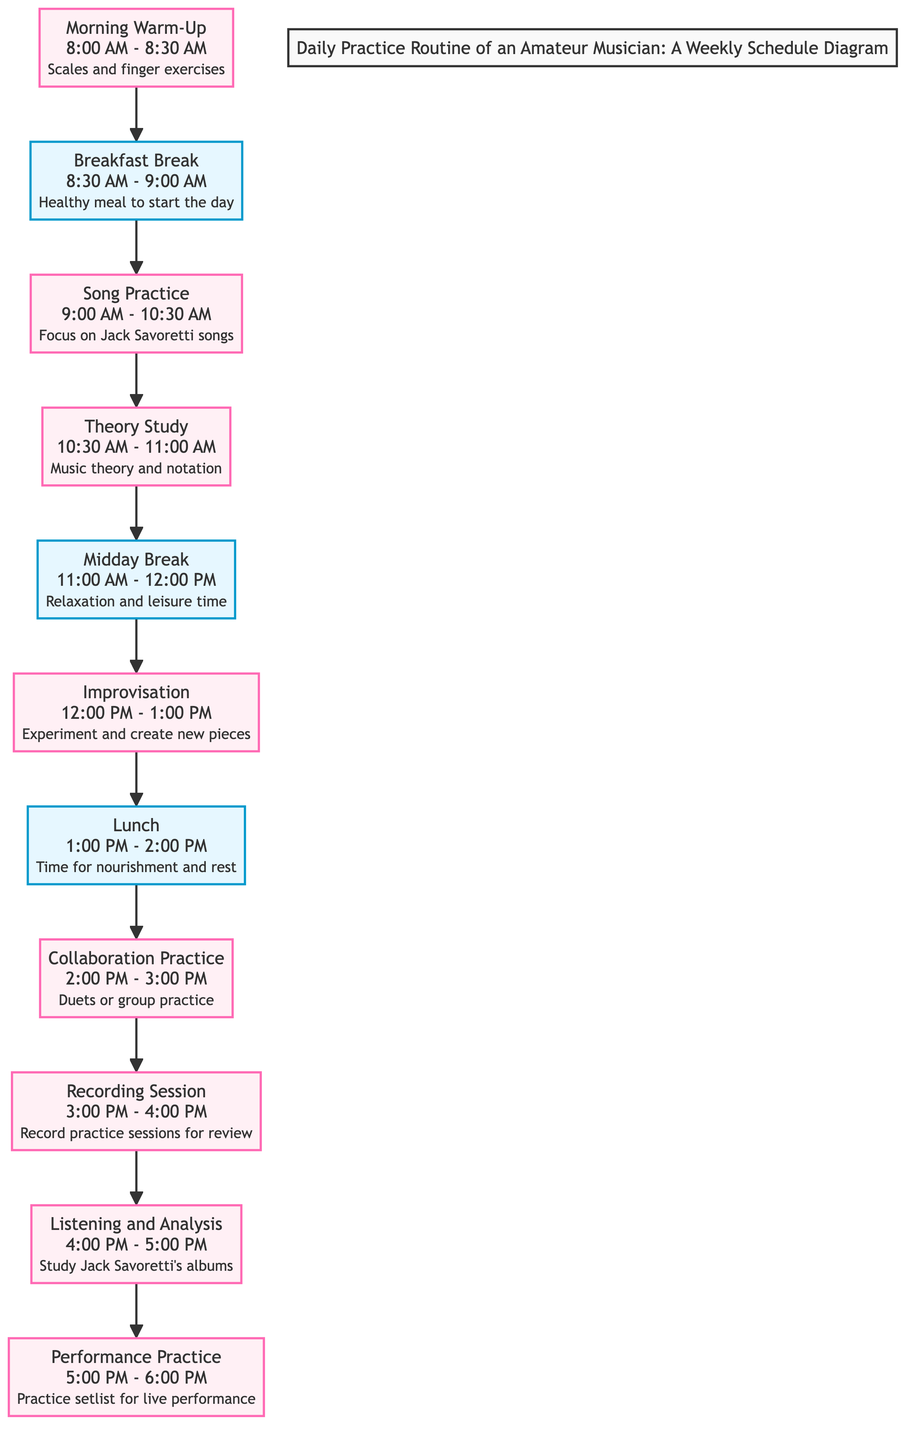What is the first activity in the daily practice routine? The first activity is "Morning Warm-Up", which is the topmost node in the diagram. There are no nodes above it, indicating that it comes first in the sequence.
Answer: Morning Warm-Up How long is the "Song Practice" scheduled for? The "Song Practice" node states that the duration is from 9:00 AM to 10:30 AM, which amounts to 1.5 hours or 90 minutes.
Answer: 90 minutes What activity follows "Midday Break"? In the flow of the diagram, "Midday Break" is followed by the "Improvisation" node, indicating that this is the next scheduled activity after the break.
Answer: Improvisation How many practice sessions are scheduled for the day? By counting the practice nodes in the diagram (not counting breaks), there are 7 distinct nodes designated for practice, indicating the number of practice sessions.
Answer: 7 What is the total number of breaks included in the daily schedule? A count of the break nodes shows there are 3 breaks in the entire daily schedule: "Breakfast Break," "Midday Break," and "Lunch."
Answer: 3 Which specific artist's songs are focused on during the "Song Practice"? The "Song Practice" node explicitly mentions that it focuses on "Jack Savoretti songs." Thus, the answer is directly found in that node.
Answer: Jack Savoretti What activity occurs between "Collaboration Practice" and "Recording Session"? The diagram shows that "Recording Session" is the activity that directly follows "Collaboration Practice," making it the activity in between.
Answer: Recording Session What is the main purpose of the "Listening and Analysis" session? The session aims to "Study Jack Savoretti's albums," as specified in the node, reflecting its educational purpose related to that artist.
Answer: Study Jack Savoretti's albums 